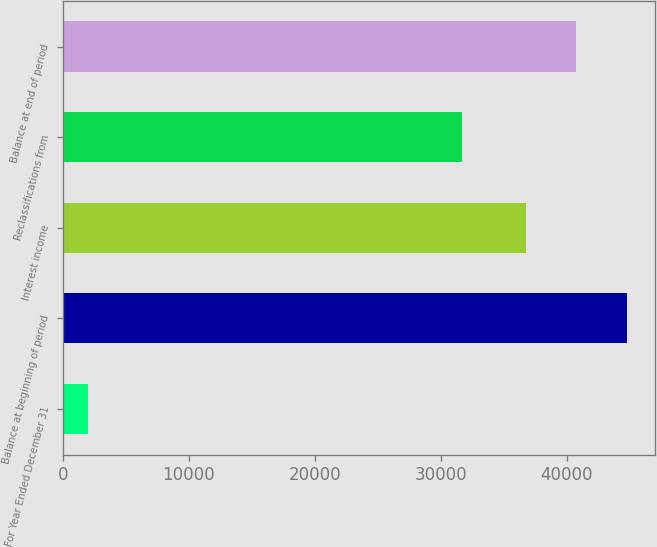<chart> <loc_0><loc_0><loc_500><loc_500><bar_chart><fcel>For Year Ended December 31<fcel>Balance at beginning of period<fcel>Interest income<fcel>Reclassifications from<fcel>Balance at end of period<nl><fcel>2013<fcel>44774.8<fcel>36727<fcel>31705<fcel>40750.9<nl></chart> 